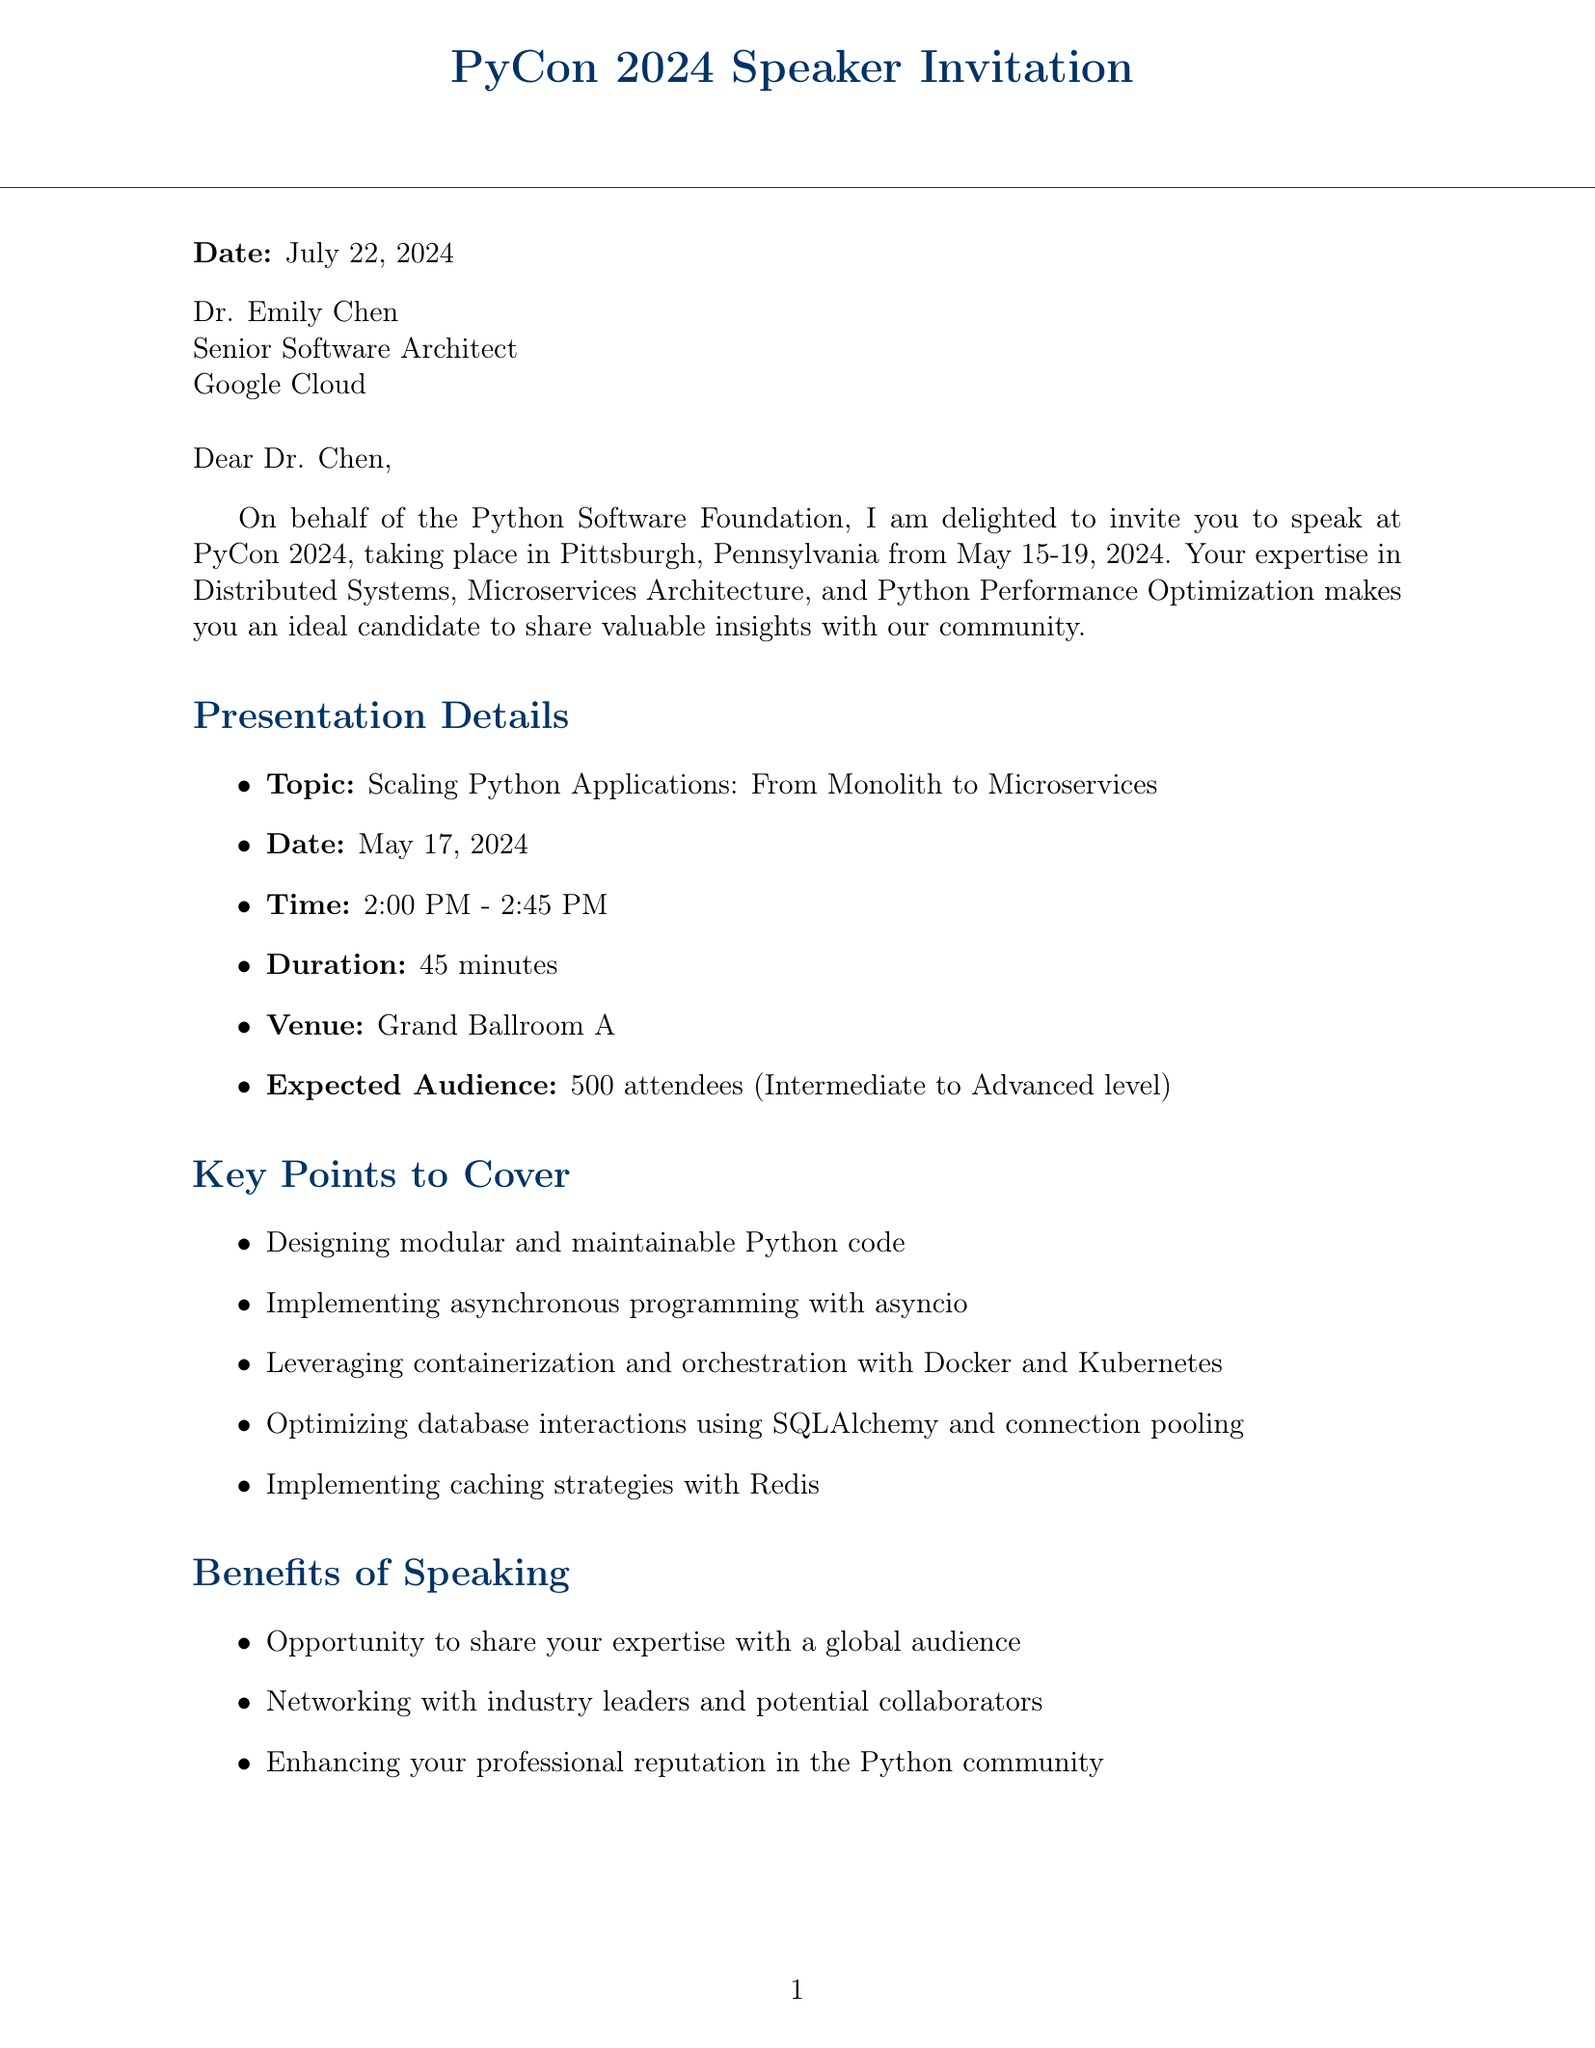What is the name of the conference? The letter states that the conference name is "PyCon 2024."
Answer: PyCon 2024 Where is the conference located? The document mentions that the conference will take place in "Pittsburgh, Pennsylvania."
Answer: Pittsburgh, Pennsylvania What is the date of the speaking slot? The speaker is invited to present on "May 17, 2024."
Answer: May 17, 2024 What is the duration of the presentation? The letter specifies that the presentation will last for "45 minutes."
Answer: 45 minutes Who is the contact person for the conference? The document lists "Sarah Johnson" as the contact person.
Answer: Sarah Johnson What is one of the key points to cover in the presentation? The presentation includes multiple key points, one of which is "Implementing asynchronous programming with asyncio."
Answer: Implementing asynchronous programming with asyncio How many expected attendees are there? The document states that there will be "500 attendees."
Answer: 500 What is the submission deadline for materials? The deadline for submission is noted as "January 15, 2024."
Answer: January 15, 2024 What kind of flight is provided for travel arrangements? The travel arrangements include a "round-trip business class flight."
Answer: round-trip business class flight 